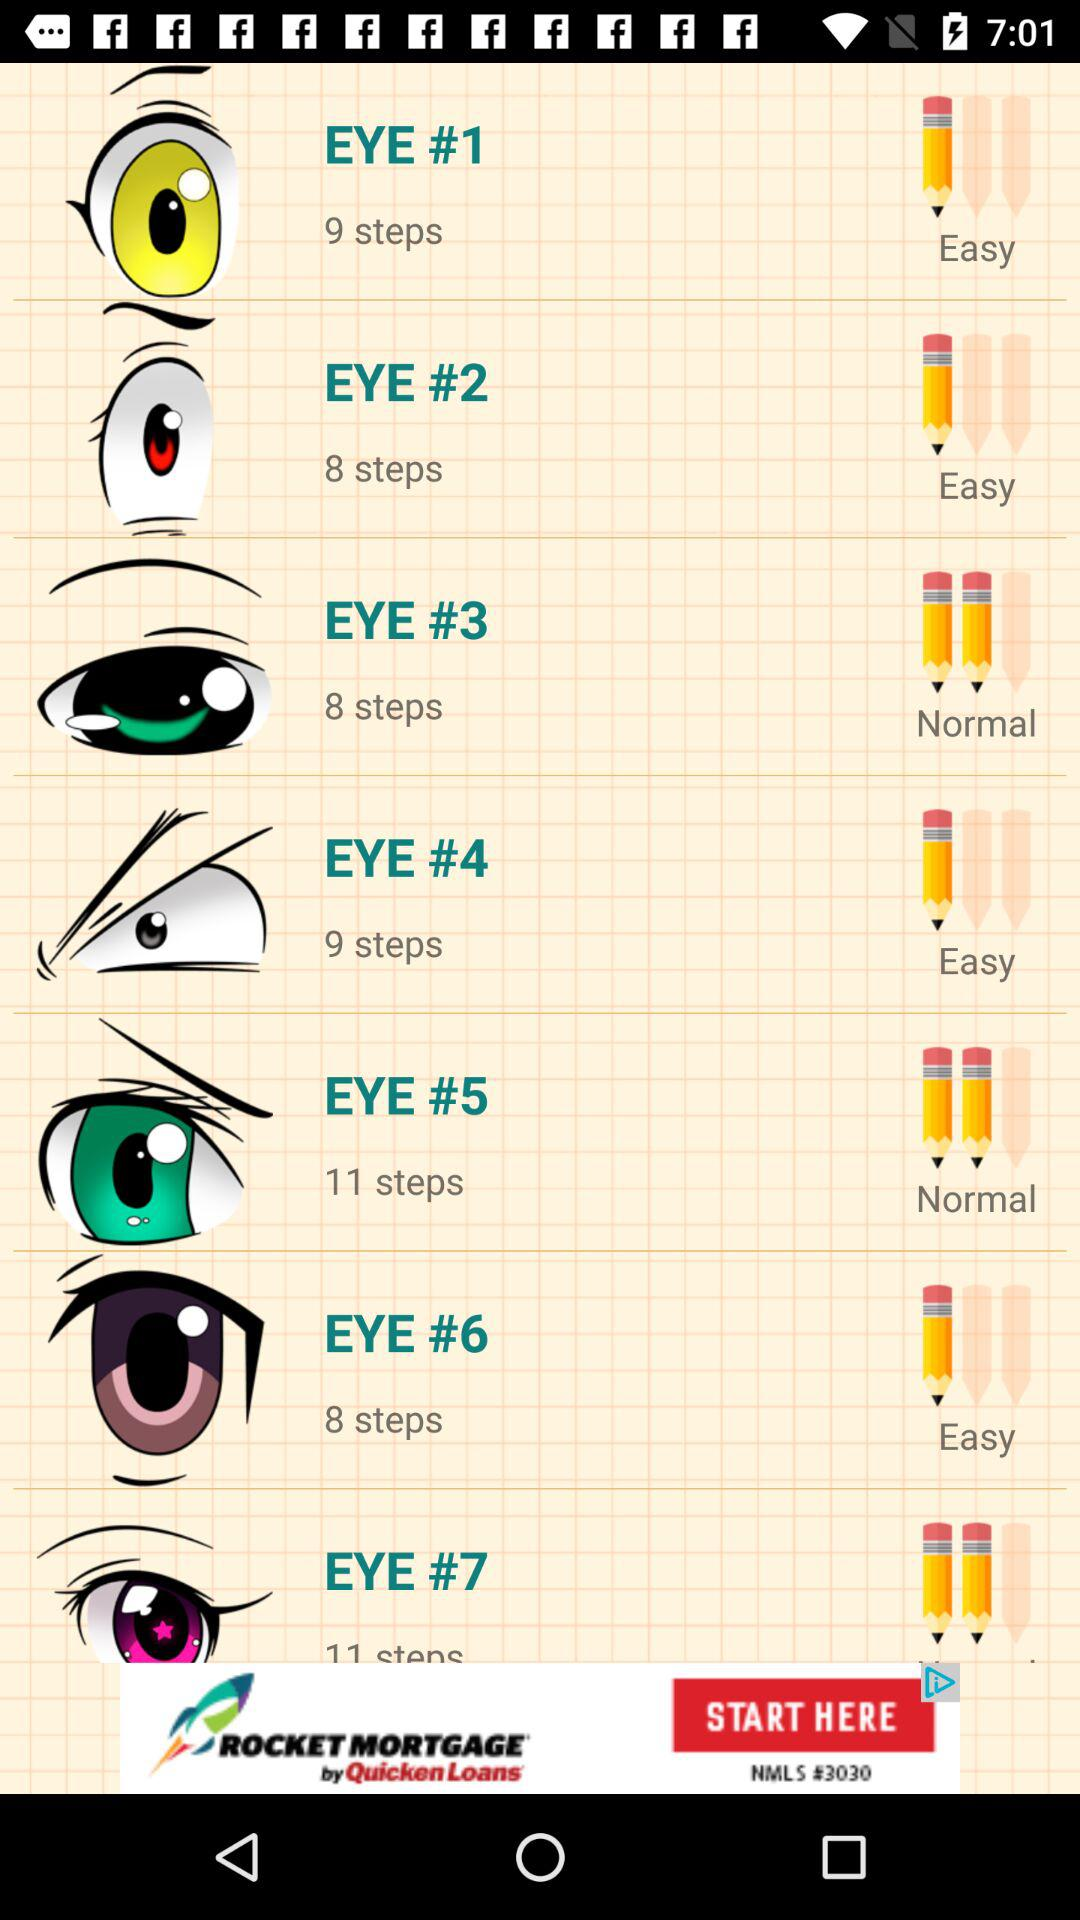How many steps does "EYE #3" have? "EYE #3" has 8 steps. 